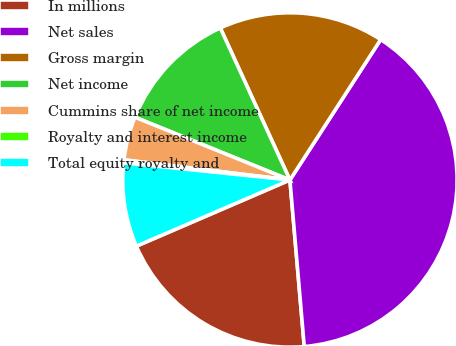<chart> <loc_0><loc_0><loc_500><loc_500><pie_chart><fcel>In millions<fcel>Net sales<fcel>Gross margin<fcel>Net income<fcel>Cummins share of net income<fcel>Royalty and interest income<fcel>Total equity royalty and<nl><fcel>19.89%<fcel>39.5%<fcel>15.97%<fcel>12.04%<fcel>4.2%<fcel>0.28%<fcel>8.12%<nl></chart> 